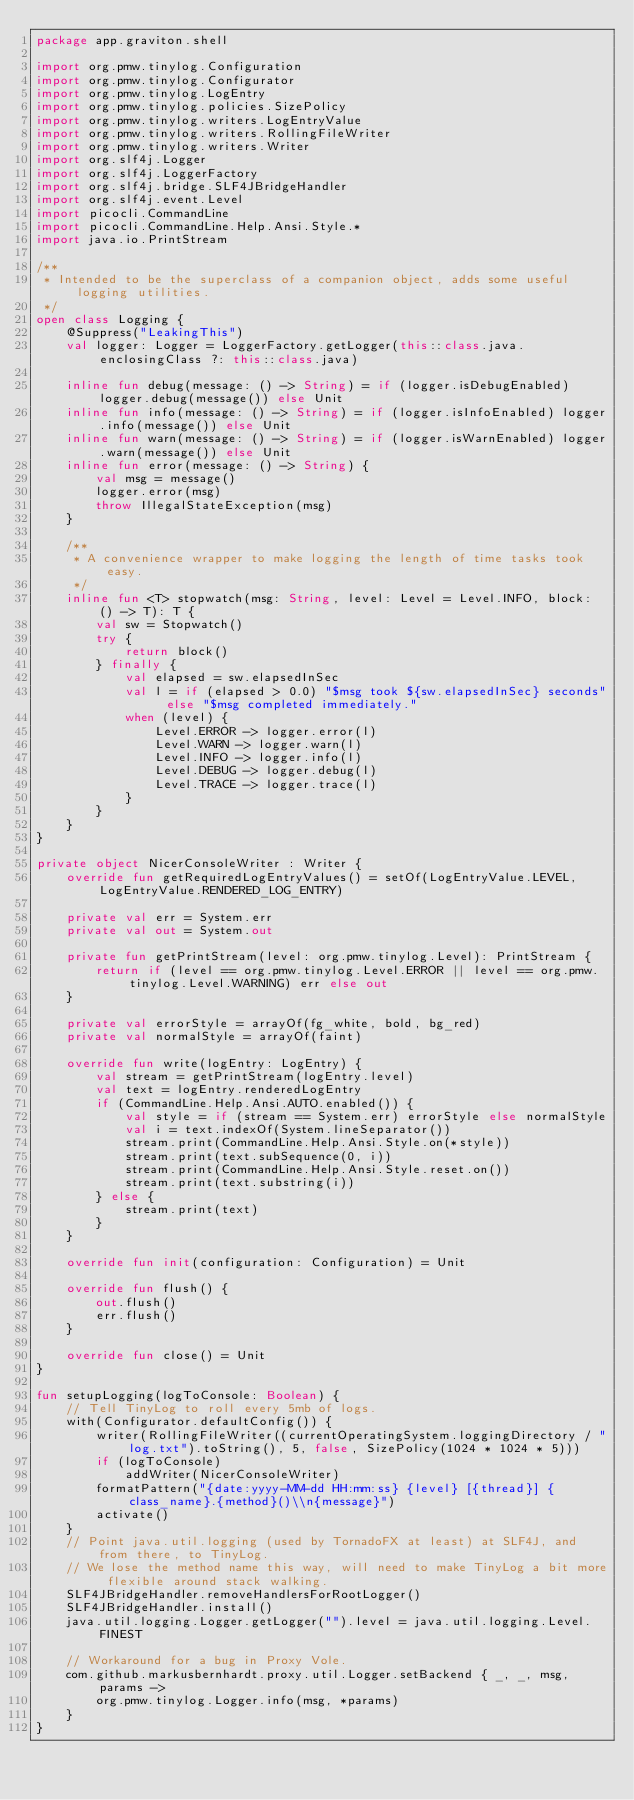<code> <loc_0><loc_0><loc_500><loc_500><_Kotlin_>package app.graviton.shell

import org.pmw.tinylog.Configuration
import org.pmw.tinylog.Configurator
import org.pmw.tinylog.LogEntry
import org.pmw.tinylog.policies.SizePolicy
import org.pmw.tinylog.writers.LogEntryValue
import org.pmw.tinylog.writers.RollingFileWriter
import org.pmw.tinylog.writers.Writer
import org.slf4j.Logger
import org.slf4j.LoggerFactory
import org.slf4j.bridge.SLF4JBridgeHandler
import org.slf4j.event.Level
import picocli.CommandLine
import picocli.CommandLine.Help.Ansi.Style.*
import java.io.PrintStream

/**
 * Intended to be the superclass of a companion object, adds some useful logging utilities.
 */
open class Logging {
    @Suppress("LeakingThis")
    val logger: Logger = LoggerFactory.getLogger(this::class.java.enclosingClass ?: this::class.java)

    inline fun debug(message: () -> String) = if (logger.isDebugEnabled) logger.debug(message()) else Unit
    inline fun info(message: () -> String) = if (logger.isInfoEnabled) logger.info(message()) else Unit
    inline fun warn(message: () -> String) = if (logger.isWarnEnabled) logger.warn(message()) else Unit
    inline fun error(message: () -> String) {
        val msg = message()
        logger.error(msg)
        throw IllegalStateException(msg)
    }

    /**
     * A convenience wrapper to make logging the length of time tasks took easy.
     */
    inline fun <T> stopwatch(msg: String, level: Level = Level.INFO, block: () -> T): T {
        val sw = Stopwatch()
        try {
            return block()
        } finally {
            val elapsed = sw.elapsedInSec
            val l = if (elapsed > 0.0) "$msg took ${sw.elapsedInSec} seconds" else "$msg completed immediately."
            when (level) {
                Level.ERROR -> logger.error(l)
                Level.WARN -> logger.warn(l)
                Level.INFO -> logger.info(l)
                Level.DEBUG -> logger.debug(l)
                Level.TRACE -> logger.trace(l)
            }
        }
    }
}

private object NicerConsoleWriter : Writer {
    override fun getRequiredLogEntryValues() = setOf(LogEntryValue.LEVEL, LogEntryValue.RENDERED_LOG_ENTRY)

    private val err = System.err
    private val out = System.out

    private fun getPrintStream(level: org.pmw.tinylog.Level): PrintStream {
        return if (level == org.pmw.tinylog.Level.ERROR || level == org.pmw.tinylog.Level.WARNING) err else out
    }

    private val errorStyle = arrayOf(fg_white, bold, bg_red)
    private val normalStyle = arrayOf(faint)

    override fun write(logEntry: LogEntry) {
        val stream = getPrintStream(logEntry.level)
        val text = logEntry.renderedLogEntry
        if (CommandLine.Help.Ansi.AUTO.enabled()) {
            val style = if (stream == System.err) errorStyle else normalStyle
            val i = text.indexOf(System.lineSeparator())
            stream.print(CommandLine.Help.Ansi.Style.on(*style))
            stream.print(text.subSequence(0, i))
            stream.print(CommandLine.Help.Ansi.Style.reset.on())
            stream.print(text.substring(i))
        } else {
            stream.print(text)
        }
    }

    override fun init(configuration: Configuration) = Unit

    override fun flush() {
        out.flush()
        err.flush()
    }

    override fun close() = Unit
}

fun setupLogging(logToConsole: Boolean) {
    // Tell TinyLog to roll every 5mb of logs.
    with(Configurator.defaultConfig()) {
        writer(RollingFileWriter((currentOperatingSystem.loggingDirectory / "log.txt").toString(), 5, false, SizePolicy(1024 * 1024 * 5)))
        if (logToConsole)
            addWriter(NicerConsoleWriter)
        formatPattern("{date:yyyy-MM-dd HH:mm:ss} {level} [{thread}] {class_name}.{method}()\\n{message}")
        activate()
    }
    // Point java.util.logging (used by TornadoFX at least) at SLF4J, and from there, to TinyLog.
    // We lose the method name this way, will need to make TinyLog a bit more flexible around stack walking.
    SLF4JBridgeHandler.removeHandlersForRootLogger()
    SLF4JBridgeHandler.install()
    java.util.logging.Logger.getLogger("").level = java.util.logging.Level.FINEST

    // Workaround for a bug in Proxy Vole.
    com.github.markusbernhardt.proxy.util.Logger.setBackend { _, _, msg, params ->
        org.pmw.tinylog.Logger.info(msg, *params)
    }
}
</code> 